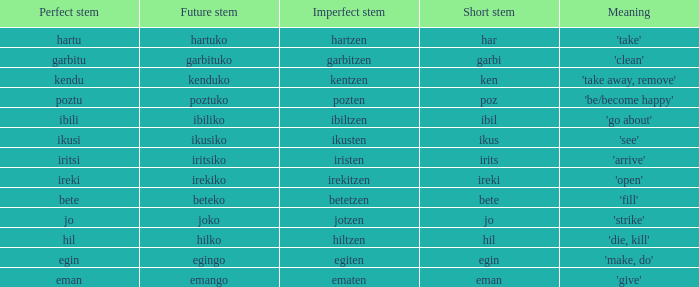What is the compact base for garbitzen? Garbi. 